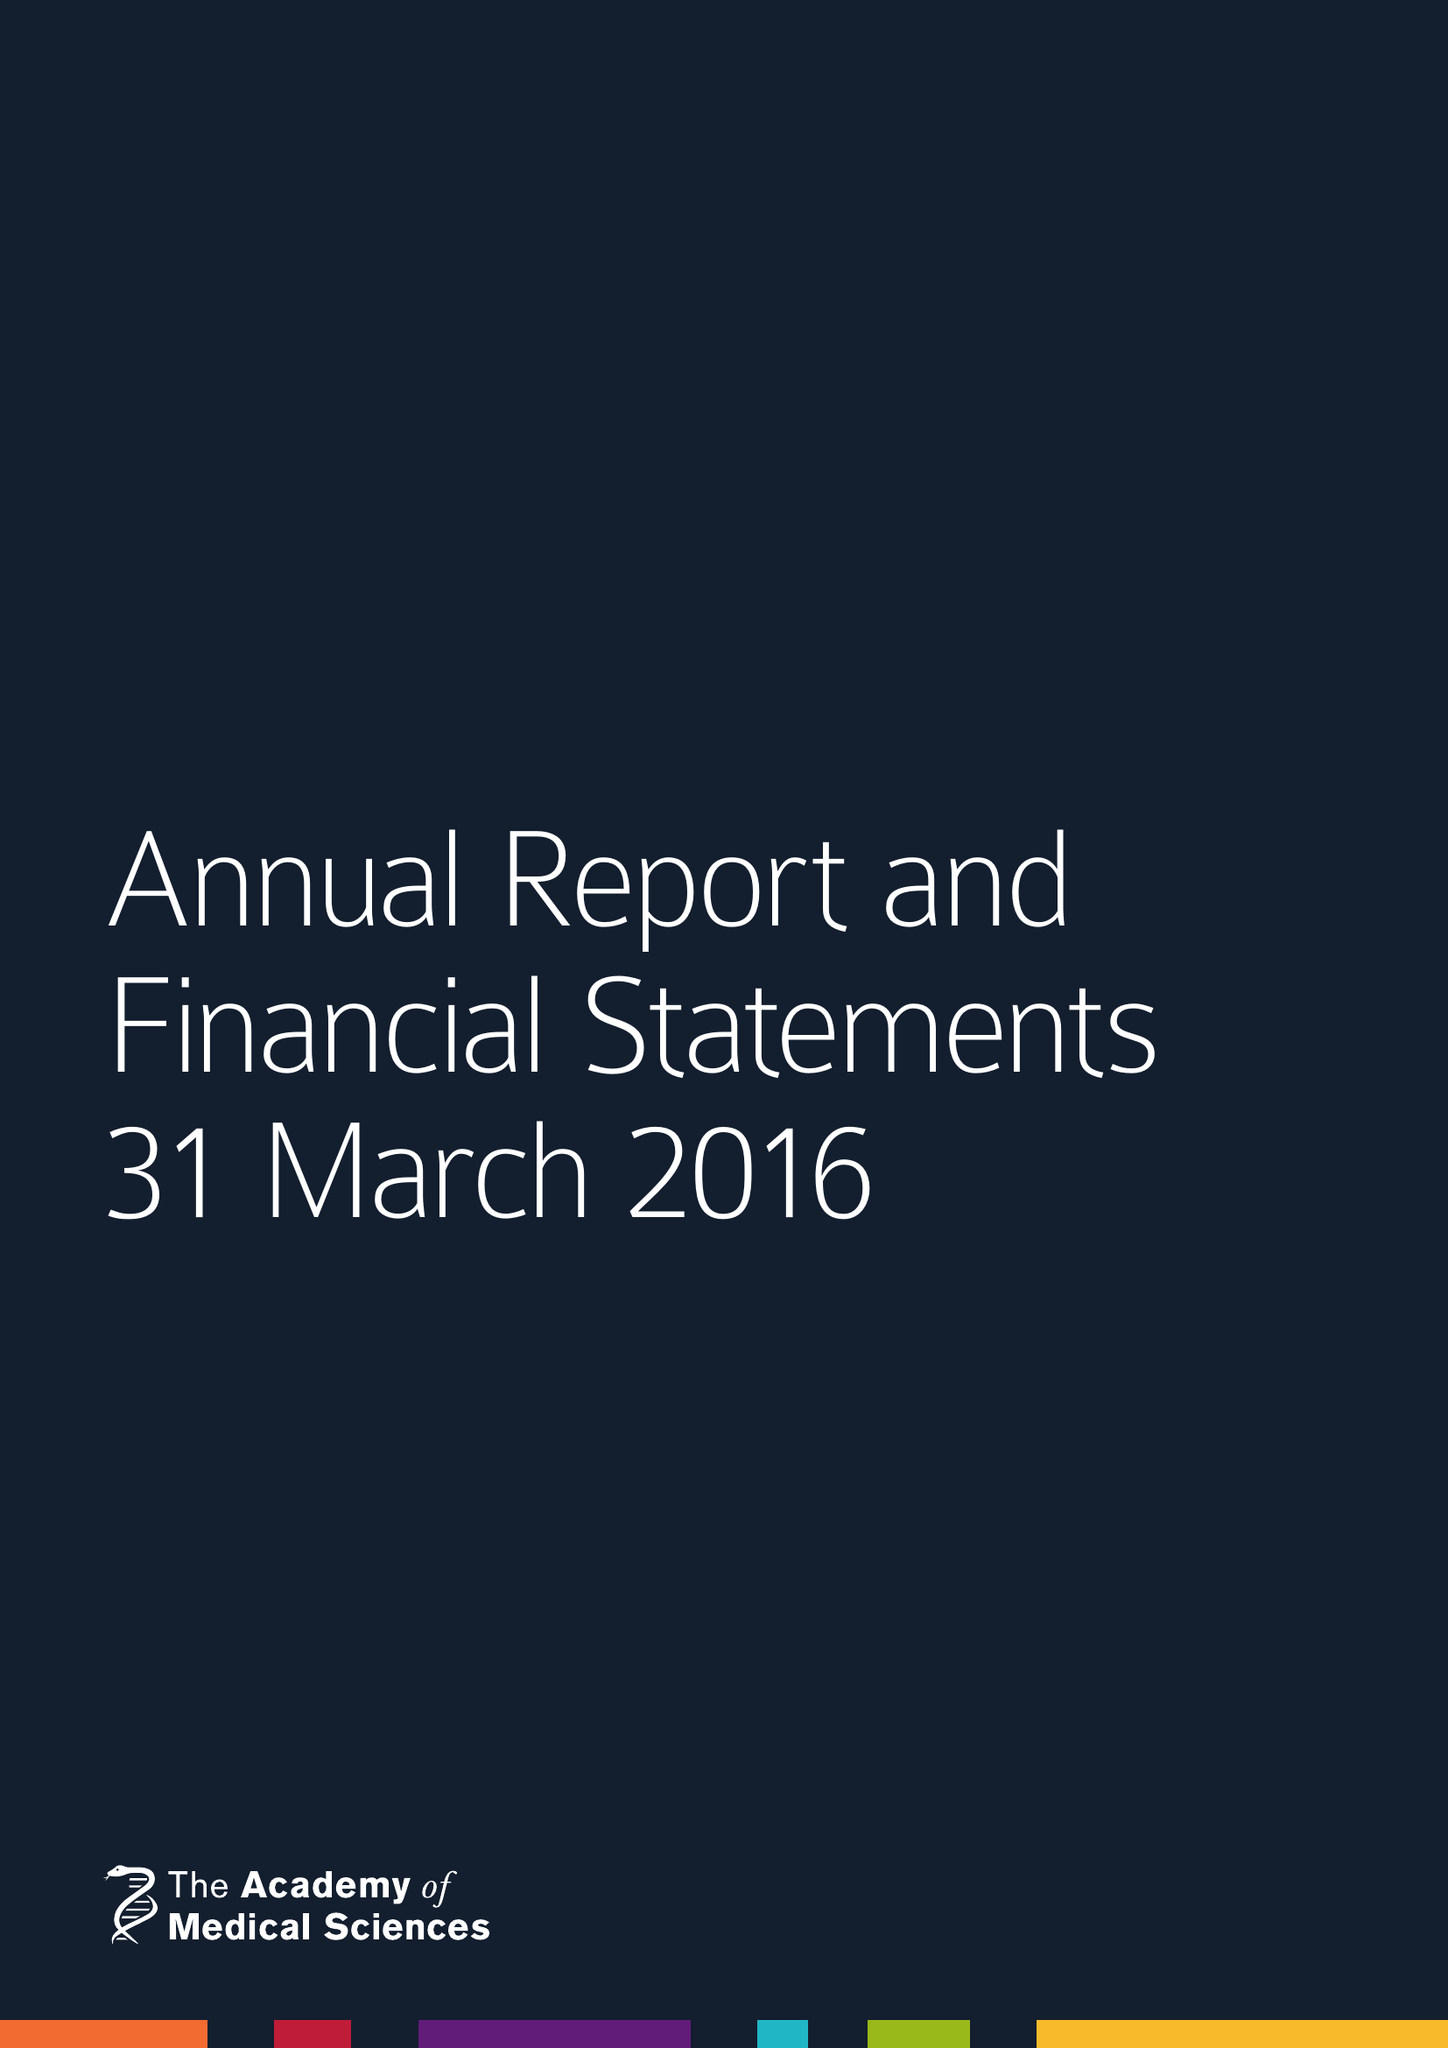What is the value for the address__postcode?
Answer the question using a single word or phrase. W1B 1QH 